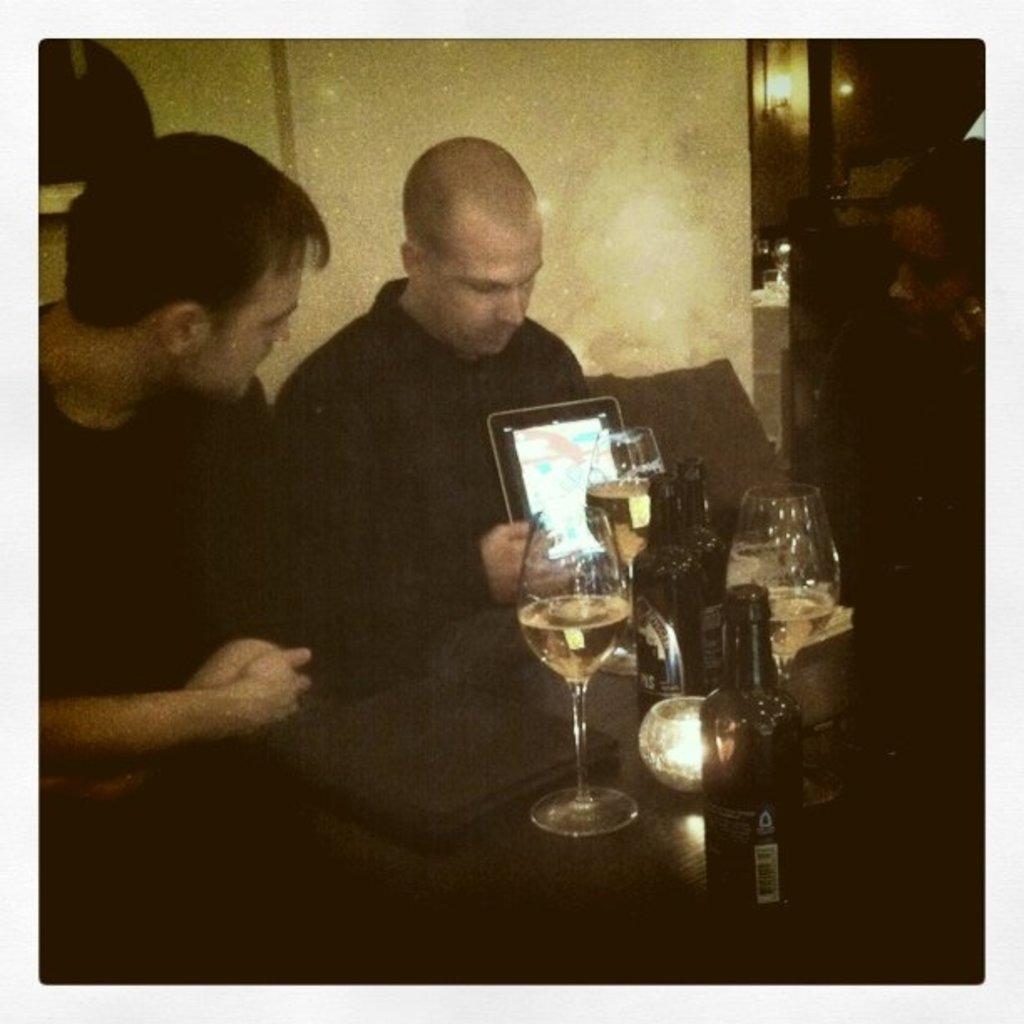Please provide a concise description of this image. In this picture there are two men and a woman sitting on the chair. There is a laptop, glass, bottle on the table. There is a light at the background. 